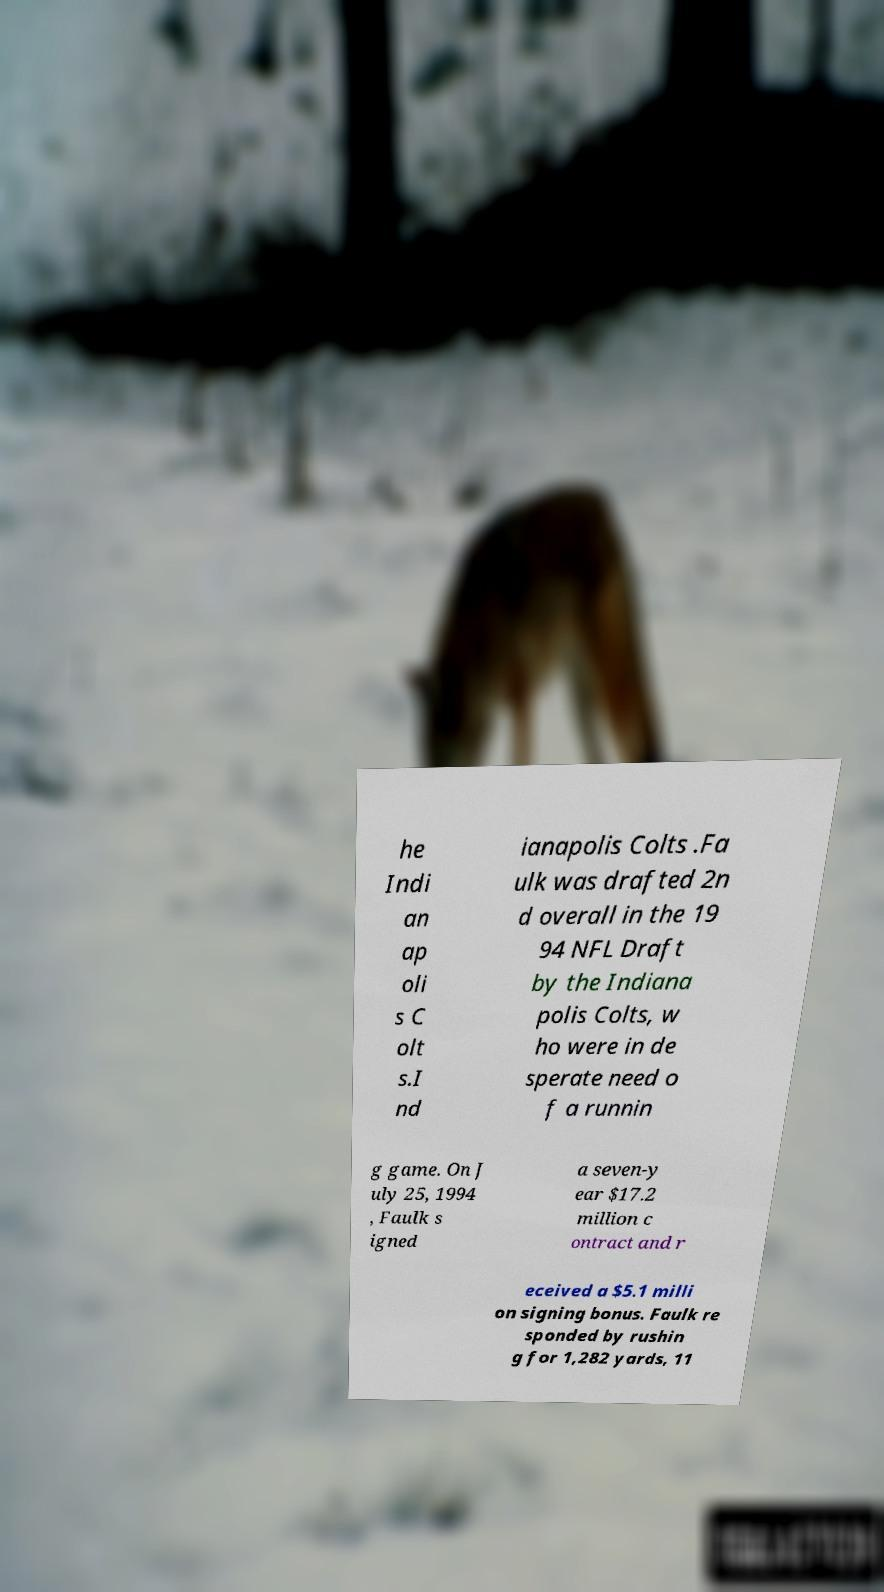Can you accurately transcribe the text from the provided image for me? he Indi an ap oli s C olt s.I nd ianapolis Colts .Fa ulk was drafted 2n d overall in the 19 94 NFL Draft by the Indiana polis Colts, w ho were in de sperate need o f a runnin g game. On J uly 25, 1994 , Faulk s igned a seven-y ear $17.2 million c ontract and r eceived a $5.1 milli on signing bonus. Faulk re sponded by rushin g for 1,282 yards, 11 